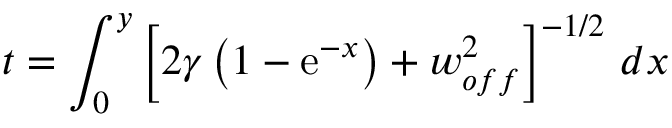<formula> <loc_0><loc_0><loc_500><loc_500>t = \int _ { 0 } ^ { y } \left [ 2 \gamma \left ( 1 - e ^ { - x } \right ) + w _ { o f f } ^ { 2 } \right ] ^ { - 1 / 2 } \, d x</formula> 